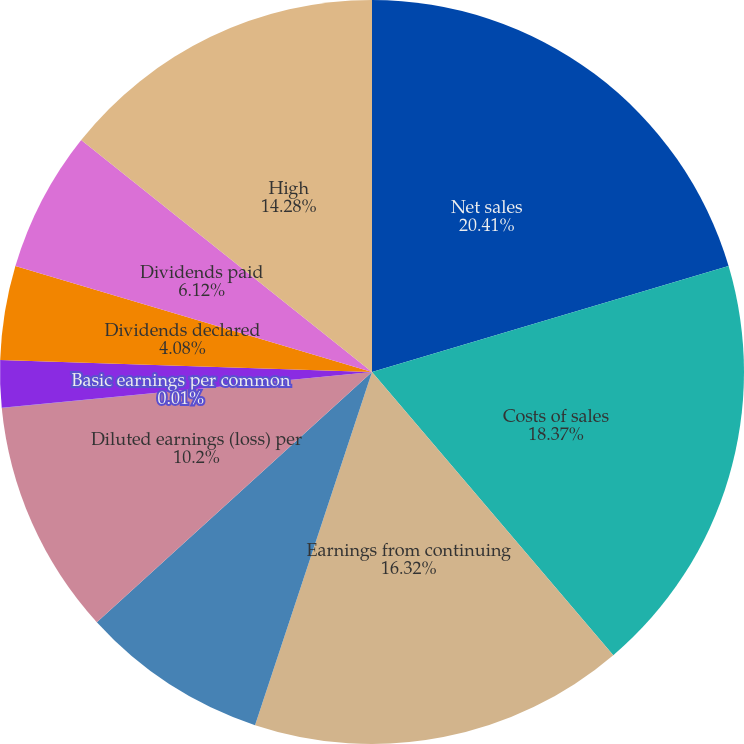Convert chart. <chart><loc_0><loc_0><loc_500><loc_500><pie_chart><fcel>Net sales<fcel>Costs of sales<fcel>Earnings from continuing<fcel>Basic earnings (loss) per<fcel>Diluted earnings (loss) per<fcel>Basic earnings per common<fcel>Diluted earnings per common<fcel>Dividends declared<fcel>Dividends paid<fcel>High<nl><fcel>20.4%<fcel>18.36%<fcel>16.32%<fcel>8.16%<fcel>10.2%<fcel>0.01%<fcel>2.05%<fcel>4.08%<fcel>6.12%<fcel>14.28%<nl></chart> 